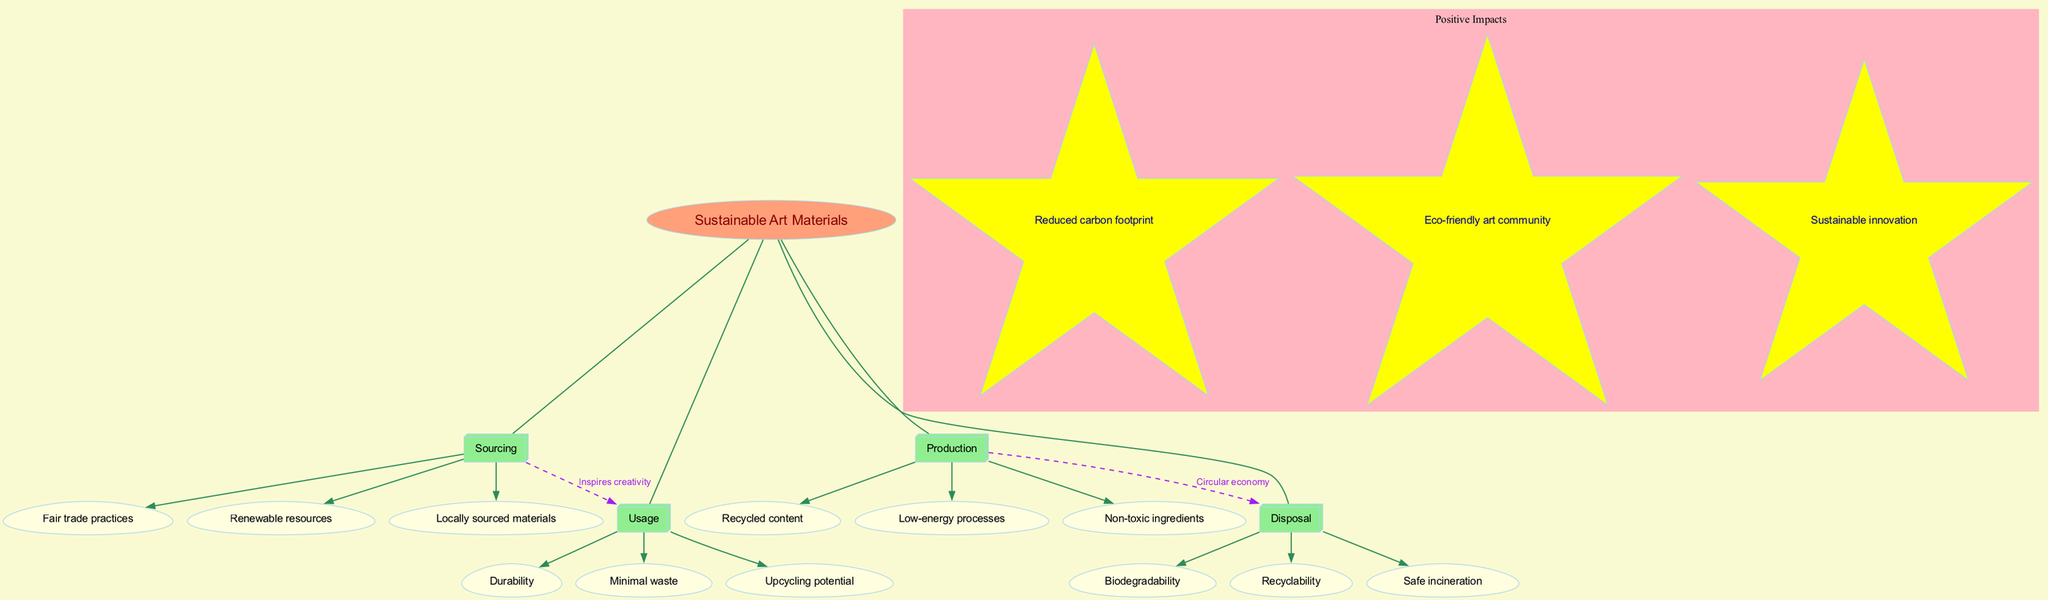What is the central theme of the diagram? The title of the diagram, which is shown prominently at the center, indicates the main focus. By identifying the labeled center, we find that it is about "Sustainable Art Materials."
Answer: Sustainable Art Materials How many main categories are there in the diagram? The main categories are visually grouped around the central theme. By counting the boxes connected to the center, we see there are four main categories: Sourcing, Production, Usage, and Disposal.
Answer: 4 What subcategory is listed under Production? Each main category branches out to its respective subcategories. By looking under the "Production" box, one notable subcategory listed is "Non-toxic ingredients."
Answer: Non-toxic ingredients What cross connection is present between Sourcing and Usage? The diagram illustrates a relationship between Sourcing and Usage with a dashed edge. The label on this edge indicates its nature: "Inspires creativity."
Answer: Inspires creativity What positive impact is associated with sustainable art materials? The positive impacts are illustrated in a separate cluster. By reviewing this cluster, we can identify one specific impact listed as "Reduced carbon footprint."
Answer: Reduced carbon footprint What connects Production to Disposal? There is a relationship indicated by a dashed line between these two main categories. The label on this connection indicates it represents a "Circular economy," showing how production practices can influence disposal.
Answer: Circular economy Which category includes "Minimal waste"? We can trace this subcategory by analyzing the connections and identifying which main category it belongs to. "Minimal waste" is clearly labeled under the "Usage" category.
Answer: Usage How many positive impacts are mentioned in the diagram? By inspecting the cluster labeled "Positive Impacts," we can count each star within this section. There are three star-shaped nodes present, representing three distinct positive impacts.
Answer: 3 Which subcategory is linked to Fair trade practices? To find the connection, we can track the subcategories under “Sourcing.” However, "Fair trade practices" does not explicitly link to another node like some others do, but it is associated with Sourcing.
Answer: Sourcing 